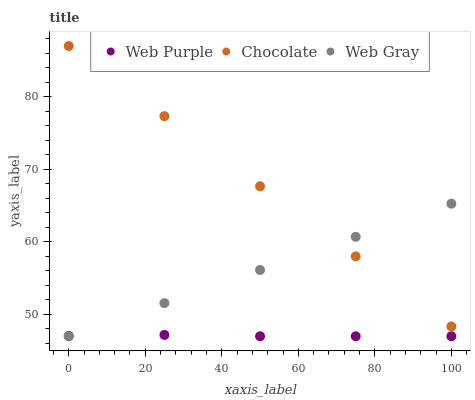Does Web Purple have the minimum area under the curve?
Answer yes or no. Yes. Does Chocolate have the maximum area under the curve?
Answer yes or no. Yes. Does Web Gray have the minimum area under the curve?
Answer yes or no. No. Does Web Gray have the maximum area under the curve?
Answer yes or no. No. Is Web Gray the smoothest?
Answer yes or no. Yes. Is Web Purple the roughest?
Answer yes or no. Yes. Is Chocolate the smoothest?
Answer yes or no. No. Is Chocolate the roughest?
Answer yes or no. No. Does Web Purple have the lowest value?
Answer yes or no. Yes. Does Chocolate have the lowest value?
Answer yes or no. No. Does Chocolate have the highest value?
Answer yes or no. Yes. Does Web Gray have the highest value?
Answer yes or no. No. Is Web Purple less than Chocolate?
Answer yes or no. Yes. Is Chocolate greater than Web Purple?
Answer yes or no. Yes. Does Web Gray intersect Web Purple?
Answer yes or no. Yes. Is Web Gray less than Web Purple?
Answer yes or no. No. Is Web Gray greater than Web Purple?
Answer yes or no. No. Does Web Purple intersect Chocolate?
Answer yes or no. No. 